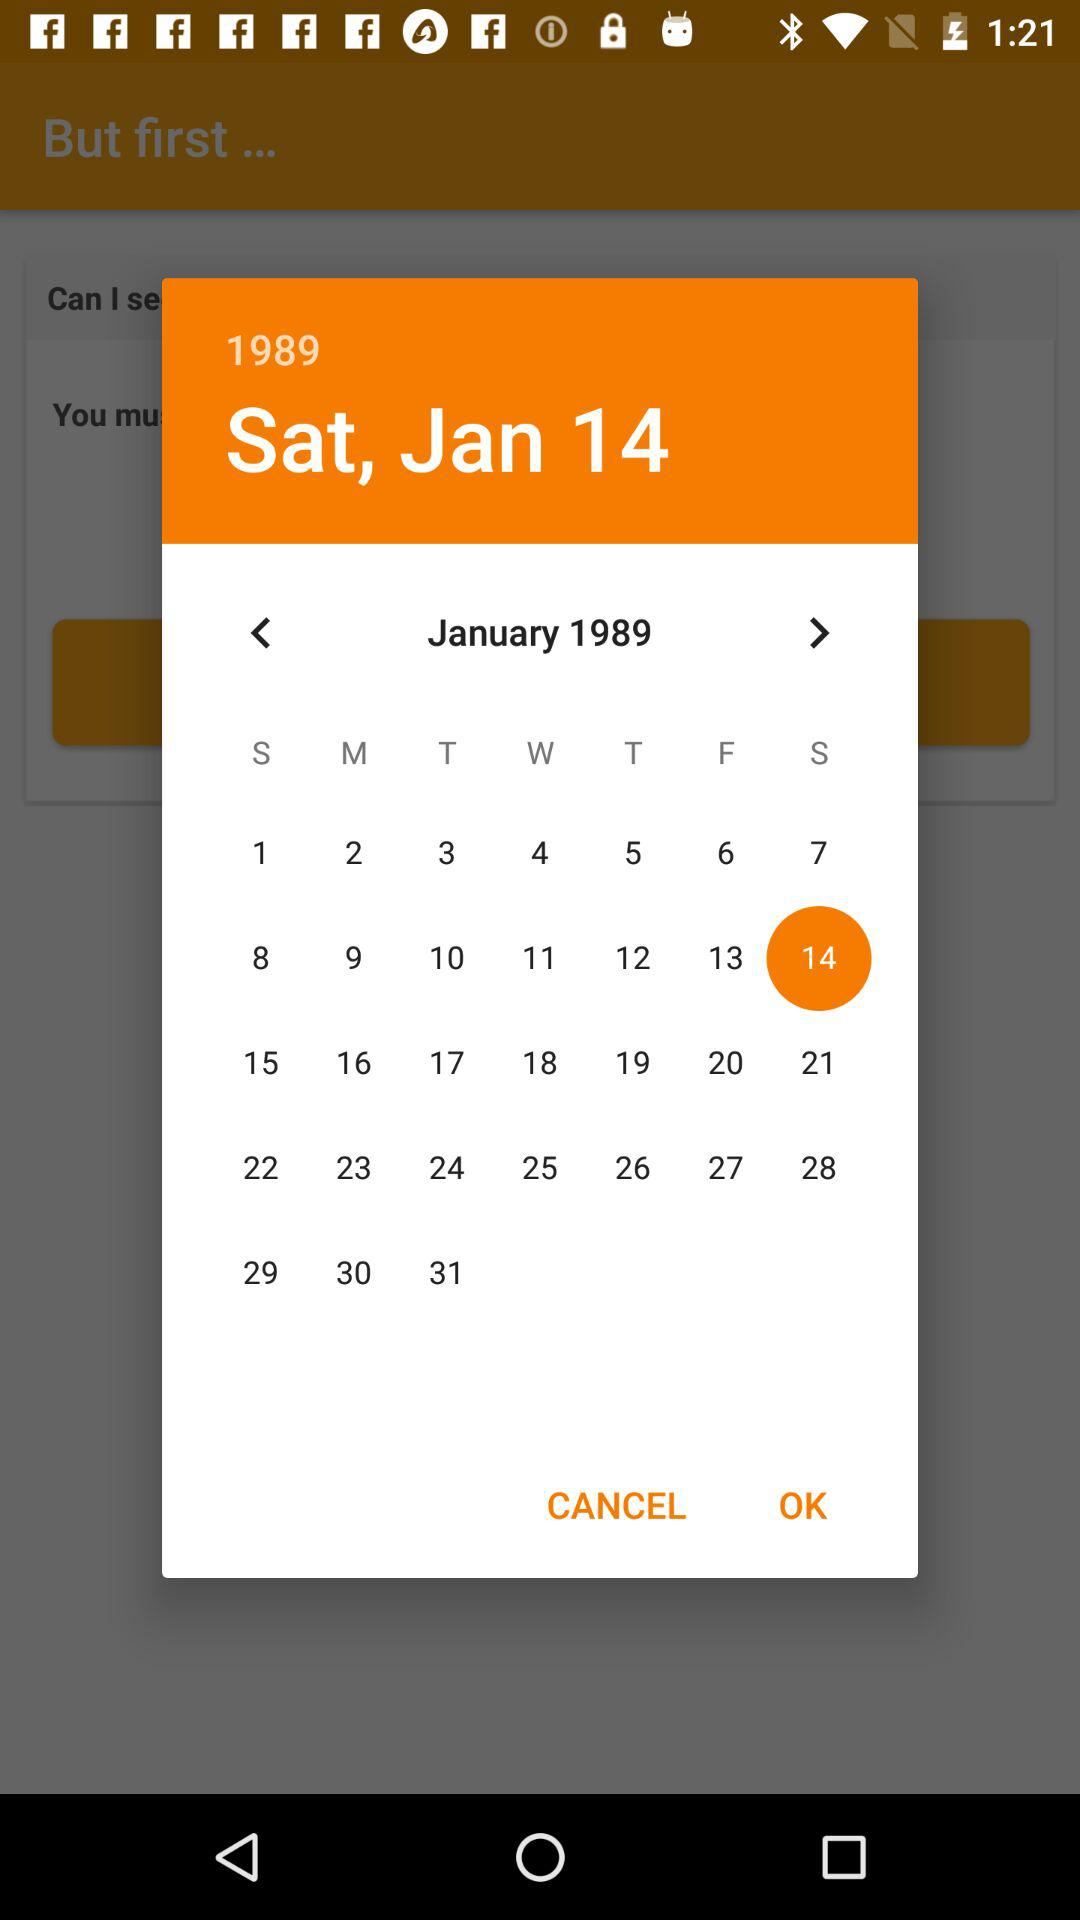What is the day and date? The day and date are Saturday, January 14, 1989, respectively. 